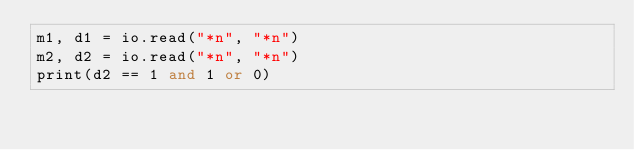<code> <loc_0><loc_0><loc_500><loc_500><_Lua_>m1, d1 = io.read("*n", "*n")
m2, d2 = io.read("*n", "*n")
print(d2 == 1 and 1 or 0)
</code> 